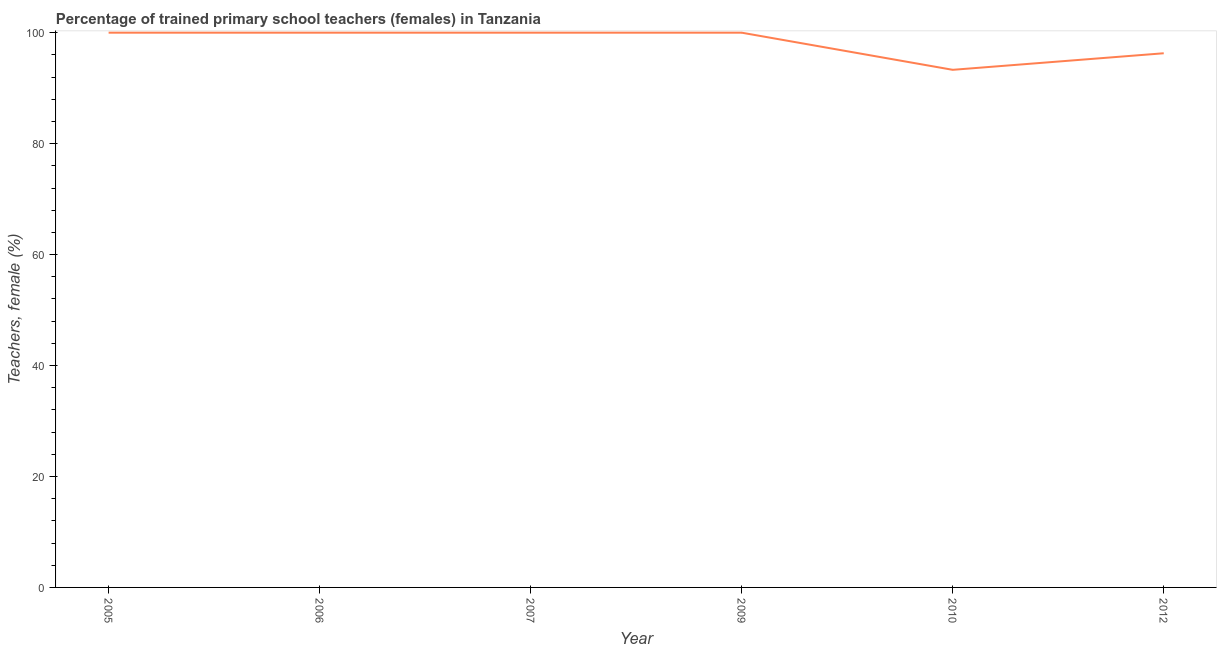What is the percentage of trained female teachers in 2010?
Provide a succinct answer. 93.31. Across all years, what is the minimum percentage of trained female teachers?
Keep it short and to the point. 93.31. In which year was the percentage of trained female teachers minimum?
Your response must be concise. 2010. What is the sum of the percentage of trained female teachers?
Your answer should be very brief. 589.6. What is the difference between the percentage of trained female teachers in 2010 and 2012?
Ensure brevity in your answer.  -2.99. What is the average percentage of trained female teachers per year?
Your response must be concise. 98.27. What is the median percentage of trained female teachers?
Keep it short and to the point. 100. In how many years, is the percentage of trained female teachers greater than 44 %?
Keep it short and to the point. 6. What is the ratio of the percentage of trained female teachers in 2006 to that in 2009?
Provide a short and direct response. 1. Is the difference between the percentage of trained female teachers in 2005 and 2007 greater than the difference between any two years?
Offer a very short reply. No. What is the difference between the highest and the lowest percentage of trained female teachers?
Offer a terse response. 6.69. In how many years, is the percentage of trained female teachers greater than the average percentage of trained female teachers taken over all years?
Ensure brevity in your answer.  4. Does the percentage of trained female teachers monotonically increase over the years?
Make the answer very short. No. How many lines are there?
Make the answer very short. 1. What is the difference between two consecutive major ticks on the Y-axis?
Give a very brief answer. 20. Does the graph contain any zero values?
Offer a very short reply. No. Does the graph contain grids?
Offer a very short reply. No. What is the title of the graph?
Keep it short and to the point. Percentage of trained primary school teachers (females) in Tanzania. What is the label or title of the Y-axis?
Keep it short and to the point. Teachers, female (%). What is the Teachers, female (%) of 2006?
Keep it short and to the point. 100. What is the Teachers, female (%) of 2009?
Your answer should be very brief. 100. What is the Teachers, female (%) in 2010?
Make the answer very short. 93.31. What is the Teachers, female (%) of 2012?
Offer a very short reply. 96.29. What is the difference between the Teachers, female (%) in 2005 and 2006?
Provide a succinct answer. 0. What is the difference between the Teachers, female (%) in 2005 and 2009?
Offer a very short reply. 0. What is the difference between the Teachers, female (%) in 2005 and 2010?
Ensure brevity in your answer.  6.69. What is the difference between the Teachers, female (%) in 2005 and 2012?
Give a very brief answer. 3.71. What is the difference between the Teachers, female (%) in 2006 and 2009?
Your response must be concise. 0. What is the difference between the Teachers, female (%) in 2006 and 2010?
Your response must be concise. 6.69. What is the difference between the Teachers, female (%) in 2006 and 2012?
Your answer should be very brief. 3.71. What is the difference between the Teachers, female (%) in 2007 and 2009?
Offer a very short reply. 0. What is the difference between the Teachers, female (%) in 2007 and 2010?
Give a very brief answer. 6.69. What is the difference between the Teachers, female (%) in 2007 and 2012?
Your answer should be compact. 3.71. What is the difference between the Teachers, female (%) in 2009 and 2010?
Keep it short and to the point. 6.69. What is the difference between the Teachers, female (%) in 2009 and 2012?
Your response must be concise. 3.71. What is the difference between the Teachers, female (%) in 2010 and 2012?
Keep it short and to the point. -2.99. What is the ratio of the Teachers, female (%) in 2005 to that in 2006?
Give a very brief answer. 1. What is the ratio of the Teachers, female (%) in 2005 to that in 2009?
Provide a short and direct response. 1. What is the ratio of the Teachers, female (%) in 2005 to that in 2010?
Your answer should be very brief. 1.07. What is the ratio of the Teachers, female (%) in 2005 to that in 2012?
Keep it short and to the point. 1.04. What is the ratio of the Teachers, female (%) in 2006 to that in 2009?
Provide a short and direct response. 1. What is the ratio of the Teachers, female (%) in 2006 to that in 2010?
Provide a short and direct response. 1.07. What is the ratio of the Teachers, female (%) in 2006 to that in 2012?
Your response must be concise. 1.04. What is the ratio of the Teachers, female (%) in 2007 to that in 2009?
Your answer should be compact. 1. What is the ratio of the Teachers, female (%) in 2007 to that in 2010?
Keep it short and to the point. 1.07. What is the ratio of the Teachers, female (%) in 2007 to that in 2012?
Keep it short and to the point. 1.04. What is the ratio of the Teachers, female (%) in 2009 to that in 2010?
Make the answer very short. 1.07. What is the ratio of the Teachers, female (%) in 2009 to that in 2012?
Ensure brevity in your answer.  1.04. 